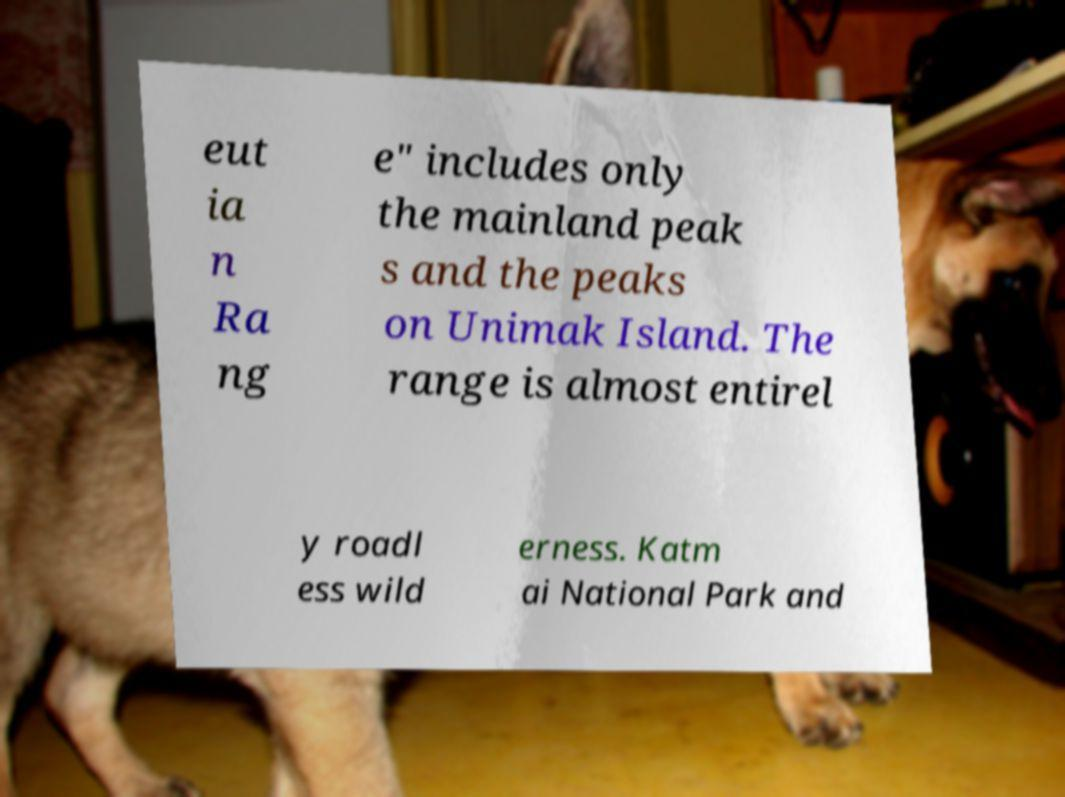Could you extract and type out the text from this image? eut ia n Ra ng e" includes only the mainland peak s and the peaks on Unimak Island. The range is almost entirel y roadl ess wild erness. Katm ai National Park and 